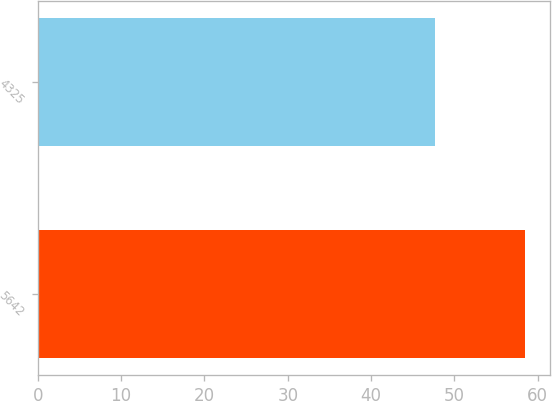<chart> <loc_0><loc_0><loc_500><loc_500><bar_chart><fcel>5642<fcel>4325<nl><fcel>58.48<fcel>47.61<nl></chart> 